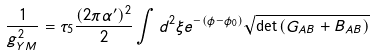Convert formula to latex. <formula><loc_0><loc_0><loc_500><loc_500>\frac { 1 } { g _ { Y M } ^ { 2 } } = \tau _ { 5 } \frac { ( 2 \pi \alpha ^ { \prime } ) ^ { 2 } } { 2 } \int d ^ { 2 } \xi { e } ^ { - ( \phi - \phi _ { 0 } ) } \sqrt { \det { ( G _ { A B } + B _ { A B } ) } }</formula> 